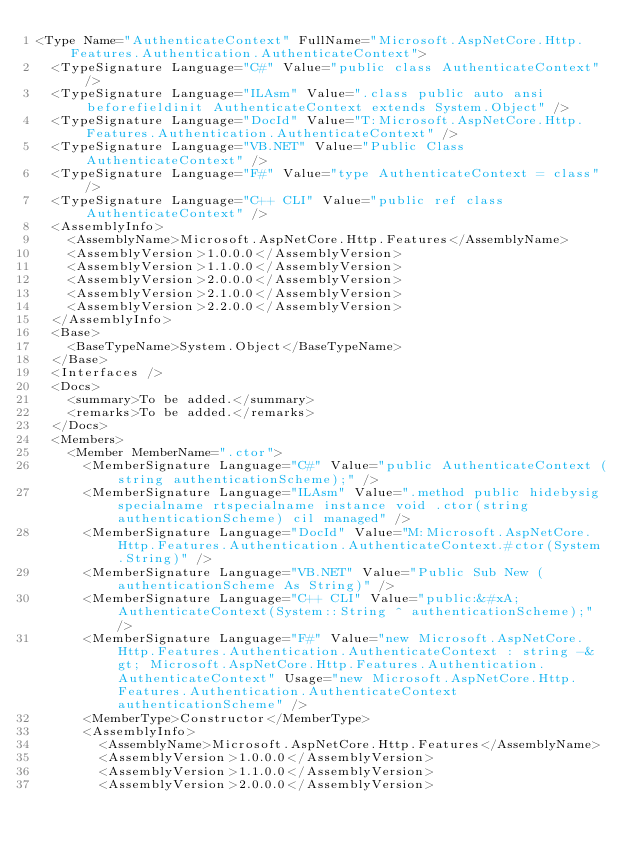<code> <loc_0><loc_0><loc_500><loc_500><_XML_><Type Name="AuthenticateContext" FullName="Microsoft.AspNetCore.Http.Features.Authentication.AuthenticateContext">
  <TypeSignature Language="C#" Value="public class AuthenticateContext" />
  <TypeSignature Language="ILAsm" Value=".class public auto ansi beforefieldinit AuthenticateContext extends System.Object" />
  <TypeSignature Language="DocId" Value="T:Microsoft.AspNetCore.Http.Features.Authentication.AuthenticateContext" />
  <TypeSignature Language="VB.NET" Value="Public Class AuthenticateContext" />
  <TypeSignature Language="F#" Value="type AuthenticateContext = class" />
  <TypeSignature Language="C++ CLI" Value="public ref class AuthenticateContext" />
  <AssemblyInfo>
    <AssemblyName>Microsoft.AspNetCore.Http.Features</AssemblyName>
    <AssemblyVersion>1.0.0.0</AssemblyVersion>
    <AssemblyVersion>1.1.0.0</AssemblyVersion>
    <AssemblyVersion>2.0.0.0</AssemblyVersion>
    <AssemblyVersion>2.1.0.0</AssemblyVersion>
    <AssemblyVersion>2.2.0.0</AssemblyVersion>
  </AssemblyInfo>
  <Base>
    <BaseTypeName>System.Object</BaseTypeName>
  </Base>
  <Interfaces />
  <Docs>
    <summary>To be added.</summary>
    <remarks>To be added.</remarks>
  </Docs>
  <Members>
    <Member MemberName=".ctor">
      <MemberSignature Language="C#" Value="public AuthenticateContext (string authenticationScheme);" />
      <MemberSignature Language="ILAsm" Value=".method public hidebysig specialname rtspecialname instance void .ctor(string authenticationScheme) cil managed" />
      <MemberSignature Language="DocId" Value="M:Microsoft.AspNetCore.Http.Features.Authentication.AuthenticateContext.#ctor(System.String)" />
      <MemberSignature Language="VB.NET" Value="Public Sub New (authenticationScheme As String)" />
      <MemberSignature Language="C++ CLI" Value="public:&#xA; AuthenticateContext(System::String ^ authenticationScheme);" />
      <MemberSignature Language="F#" Value="new Microsoft.AspNetCore.Http.Features.Authentication.AuthenticateContext : string -&gt; Microsoft.AspNetCore.Http.Features.Authentication.AuthenticateContext" Usage="new Microsoft.AspNetCore.Http.Features.Authentication.AuthenticateContext authenticationScheme" />
      <MemberType>Constructor</MemberType>
      <AssemblyInfo>
        <AssemblyName>Microsoft.AspNetCore.Http.Features</AssemblyName>
        <AssemblyVersion>1.0.0.0</AssemblyVersion>
        <AssemblyVersion>1.1.0.0</AssemblyVersion>
        <AssemblyVersion>2.0.0.0</AssemblyVersion></code> 